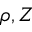Convert formula to latex. <formula><loc_0><loc_0><loc_500><loc_500>\rho , Z</formula> 